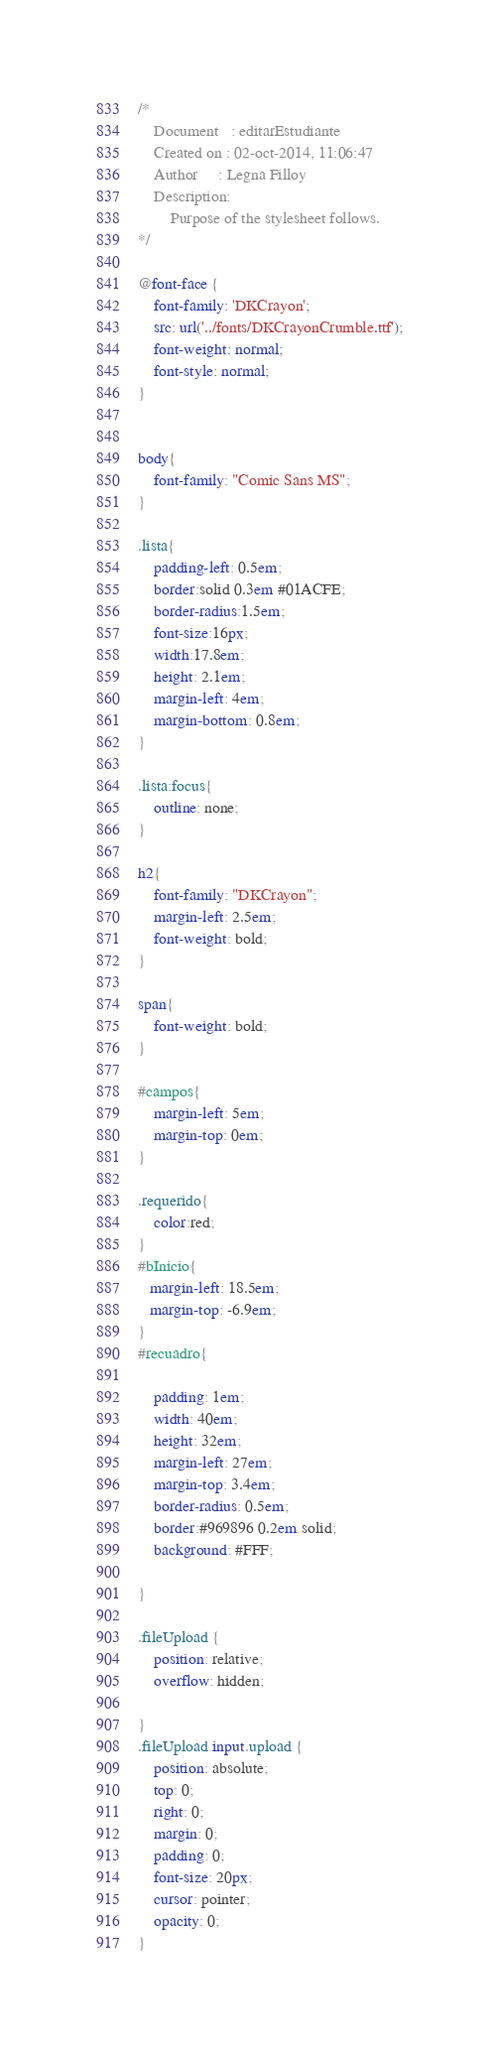Convert code to text. <code><loc_0><loc_0><loc_500><loc_500><_CSS_>/* 
    Document   : editarEstudiante
    Created on : 02-oct-2014, 11:06:47
    Author     : Legna Filloy
    Description:
        Purpose of the stylesheet follows.
*/

@font-face {
    font-family: 'DKCrayon';
    src: url('../fonts/DKCrayonCrumble.ttf');
    font-weight: normal;
    font-style: normal;
}


body{
    font-family: "Comic Sans MS";
}

.lista{
    padding-left: 0.5em;
    border:solid 0.3em #01ACFE;
    border-radius:1.5em;
    font-size:16px;
    width:17.8em;
    height: 2.1em;
    margin-left: 4em;
    margin-bottom: 0.8em; 	  
}

.lista:focus{
    outline: none;
}

h2{
    font-family: "DKCrayon"; 
    margin-left: 2.5em;
    font-weight: bold;
}

span{
    font-weight: bold;   
}

#campos{
    margin-left: 5em;
    margin-top: 0em;
}

.requerido{
    color:red;
}
#bInicio{
   margin-left: 18.5em;
   margin-top: -6.9em;
}
#recuadro{
   
    padding: 1em;
    width: 40em;
    height: 32em;
    margin-left: 27em;
    margin-top: 3.4em;
    border-radius: 0.5em;
    border:#969896 0.2em solid;
    background: #FFF;

}

.fileUpload {
    position: relative;
    overflow: hidden;

}
.fileUpload input.upload {
    position: absolute;
    top: 0;
    right: 0;
    margin: 0;
    padding: 0;
    font-size: 20px;
    cursor: pointer;
    opacity: 0;
}
</code> 